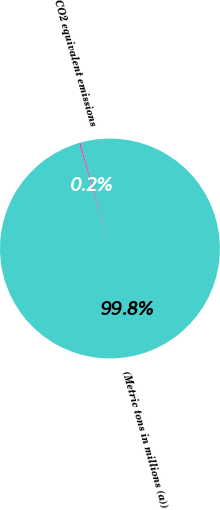Convert chart to OTSL. <chart><loc_0><loc_0><loc_500><loc_500><pie_chart><fcel>(Metric tons in millions (a))<fcel>CO2 equivalent emissions<nl><fcel>99.85%<fcel>0.15%<nl></chart> 